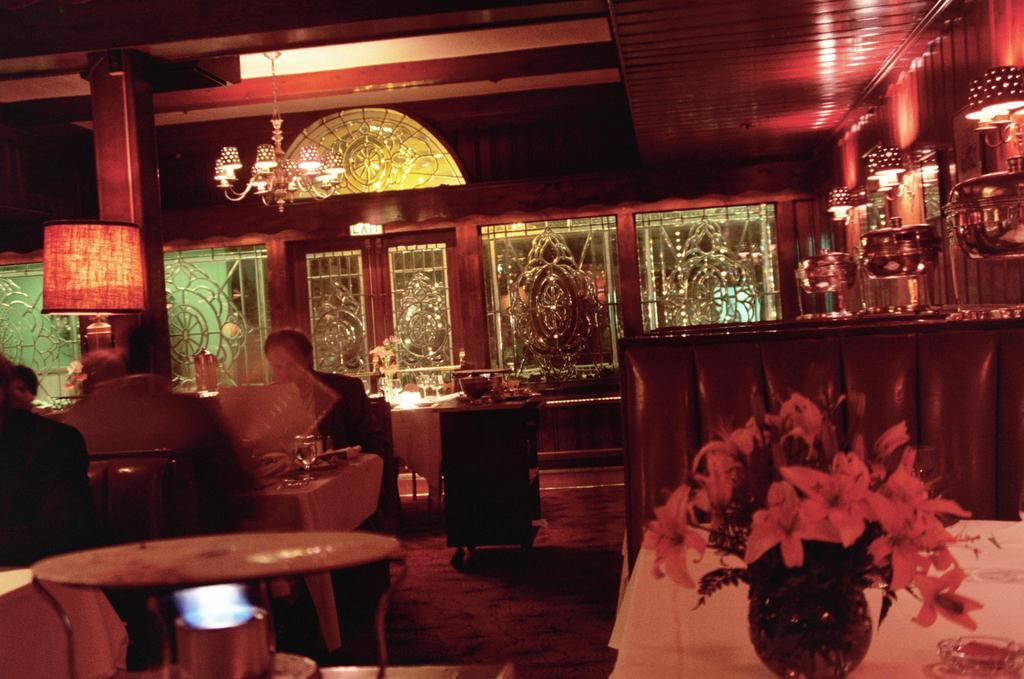Please provide a concise description of this image. Here in this picture the place look like a restaurant. There are two men sitting in front of the table. There is a lamp. There is a lightnings. There is a window. There are some vessels. There is a flower pot. There is a stroller. 